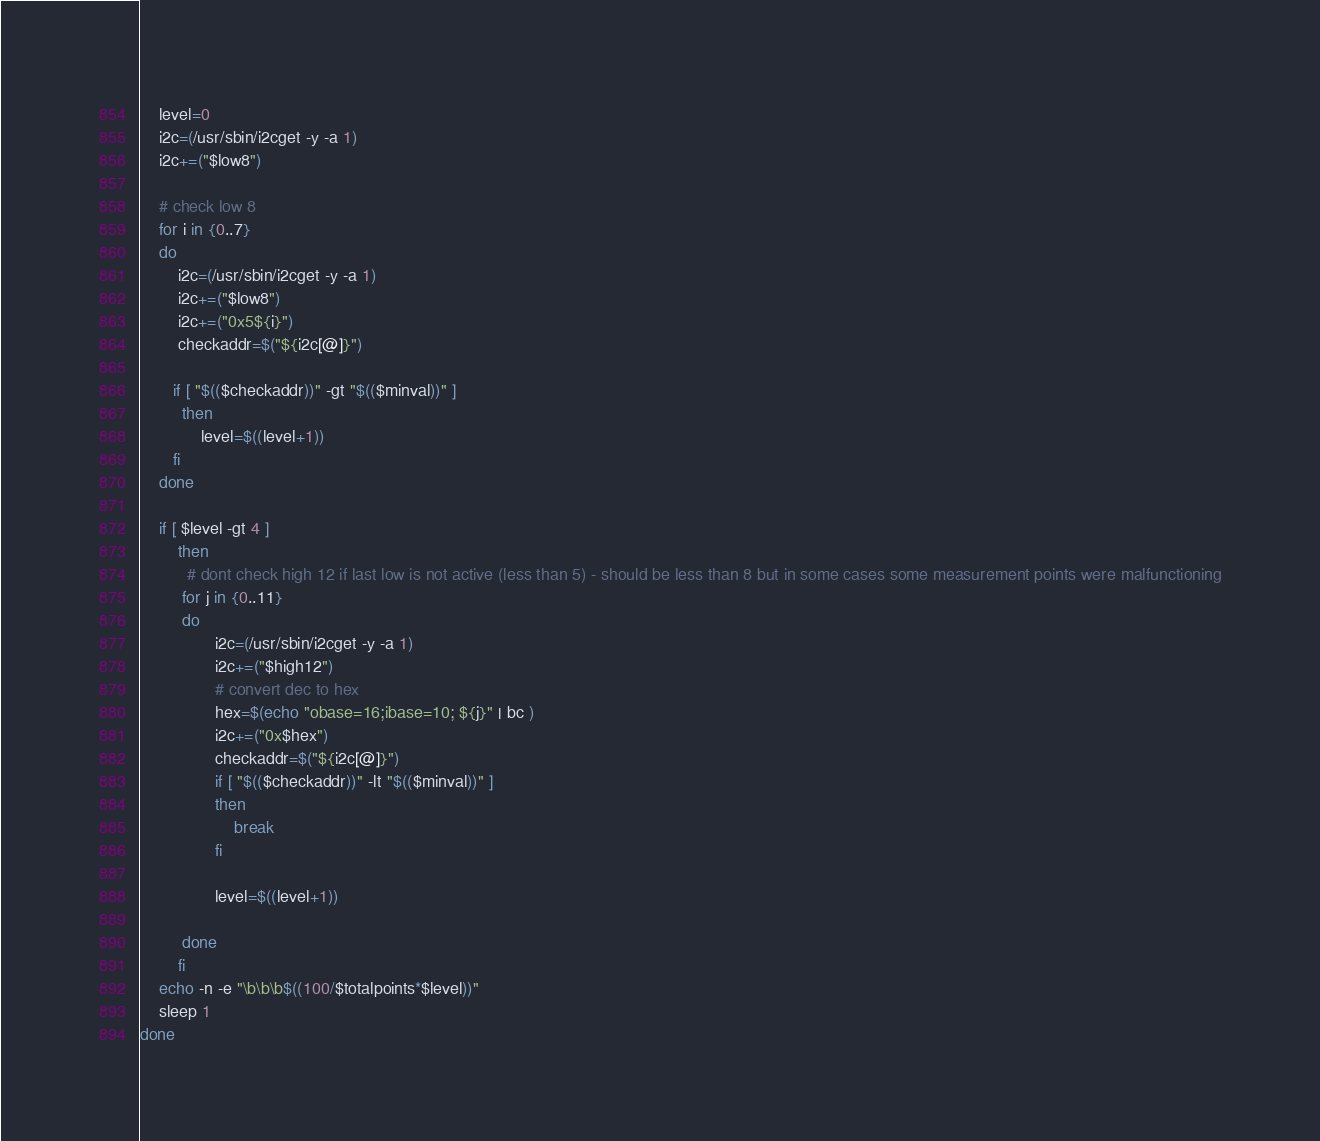Convert code to text. <code><loc_0><loc_0><loc_500><loc_500><_Bash_>    level=0
    i2c=(/usr/sbin/i2cget -y -a 1)
    i2c+=("$low8")

    # check low 8
    for i in {0..7}
    do
        i2c=(/usr/sbin/i2cget -y -a 1)
        i2c+=("$low8")
        i2c+=("0x5${i}")
        checkaddr=$("${i2c[@]}")

       if [ "$(($checkaddr))" -gt "$(($minval))" ]
         then
             level=$((level+1))
       fi
    done
    
    if [ $level -gt 4 ]
        then
          # dont check high 12 if last low is not active (less than 5) - should be less than 8 but in some cases some measurement points were malfunctioning
         for j in {0..11}
         do
                i2c=(/usr/sbin/i2cget -y -a 1)
                i2c+=("$high12")
                # convert dec to hex
                hex=$(echo "obase=16;ibase=10; ${j}" | bc )
                i2c+=("0x$hex")
                checkaddr=$("${i2c[@]}")
                if [ "$(($checkaddr))" -lt "$(($minval))" ]
                then
                    break
                fi

                level=$((level+1))

         done
        fi
    echo -n -e "\b\b\b$((100/$totalpoints*$level))"
    sleep 1
done
</code> 